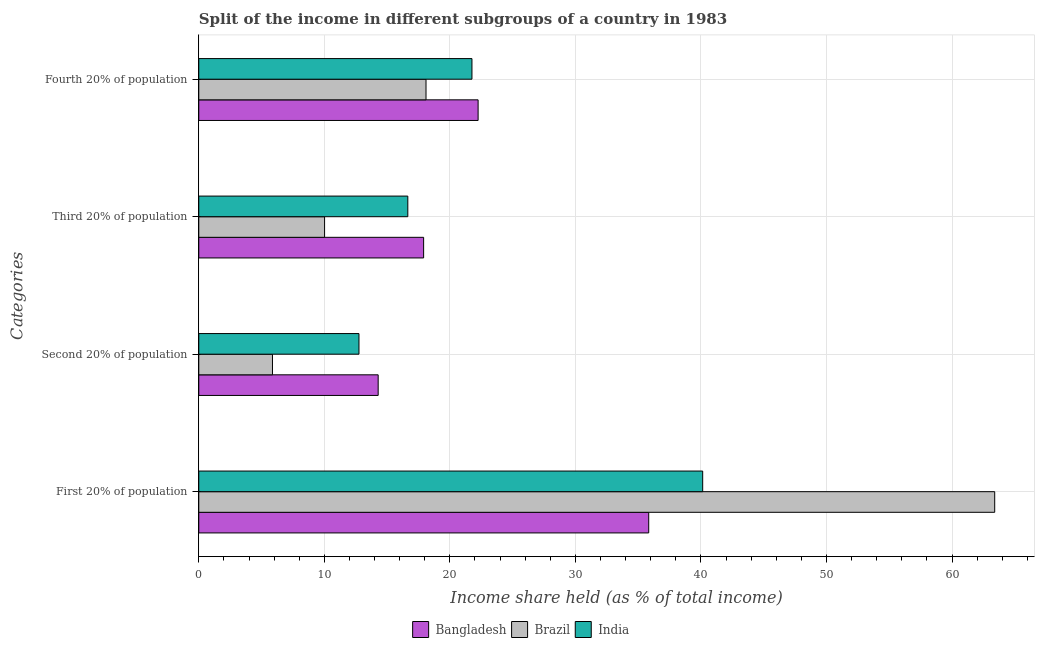How many different coloured bars are there?
Give a very brief answer. 3. How many groups of bars are there?
Your answer should be very brief. 4. Are the number of bars per tick equal to the number of legend labels?
Keep it short and to the point. Yes. Are the number of bars on each tick of the Y-axis equal?
Make the answer very short. Yes. How many bars are there on the 4th tick from the top?
Your response must be concise. 3. How many bars are there on the 3rd tick from the bottom?
Your answer should be very brief. 3. What is the label of the 4th group of bars from the top?
Provide a short and direct response. First 20% of population. What is the share of the income held by first 20% of the population in India?
Give a very brief answer. 40.14. Across all countries, what is the maximum share of the income held by second 20% of the population?
Offer a very short reply. 14.29. Across all countries, what is the minimum share of the income held by first 20% of the population?
Your answer should be very brief. 35.84. In which country was the share of the income held by fourth 20% of the population maximum?
Ensure brevity in your answer.  Bangladesh. In which country was the share of the income held by third 20% of the population minimum?
Provide a succinct answer. Brazil. What is the total share of the income held by second 20% of the population in the graph?
Your answer should be very brief. 32.92. What is the difference between the share of the income held by second 20% of the population in India and that in Bangladesh?
Your response must be concise. -1.53. What is the difference between the share of the income held by first 20% of the population in India and the share of the income held by fourth 20% of the population in Brazil?
Ensure brevity in your answer.  22.04. What is the average share of the income held by first 20% of the population per country?
Offer a terse response. 46.46. What is the difference between the share of the income held by second 20% of the population and share of the income held by third 20% of the population in Brazil?
Make the answer very short. -4.15. In how many countries, is the share of the income held by second 20% of the population greater than 34 %?
Offer a terse response. 0. What is the ratio of the share of the income held by second 20% of the population in India to that in Brazil?
Keep it short and to the point. 2.17. What is the difference between the highest and the second highest share of the income held by fourth 20% of the population?
Offer a very short reply. 0.49. What is the difference between the highest and the lowest share of the income held by third 20% of the population?
Offer a terse response. 7.89. Is the sum of the share of the income held by first 20% of the population in Bangladesh and Brazil greater than the maximum share of the income held by fourth 20% of the population across all countries?
Your response must be concise. Yes. What does the 3rd bar from the top in First 20% of population represents?
Your answer should be very brief. Bangladesh. Are all the bars in the graph horizontal?
Give a very brief answer. Yes. How many countries are there in the graph?
Offer a very short reply. 3. Does the graph contain grids?
Offer a very short reply. Yes. Where does the legend appear in the graph?
Provide a succinct answer. Bottom center. How many legend labels are there?
Keep it short and to the point. 3. How are the legend labels stacked?
Provide a succinct answer. Horizontal. What is the title of the graph?
Offer a terse response. Split of the income in different subgroups of a country in 1983. Does "Greece" appear as one of the legend labels in the graph?
Your answer should be very brief. No. What is the label or title of the X-axis?
Ensure brevity in your answer.  Income share held (as % of total income). What is the label or title of the Y-axis?
Provide a succinct answer. Categories. What is the Income share held (as % of total income) of Bangladesh in First 20% of population?
Offer a terse response. 35.84. What is the Income share held (as % of total income) of Brazil in First 20% of population?
Your answer should be compact. 63.4. What is the Income share held (as % of total income) in India in First 20% of population?
Your answer should be compact. 40.14. What is the Income share held (as % of total income) of Bangladesh in Second 20% of population?
Keep it short and to the point. 14.29. What is the Income share held (as % of total income) in Brazil in Second 20% of population?
Your answer should be very brief. 5.87. What is the Income share held (as % of total income) in India in Second 20% of population?
Provide a short and direct response. 12.76. What is the Income share held (as % of total income) in Bangladesh in Third 20% of population?
Keep it short and to the point. 17.91. What is the Income share held (as % of total income) in Brazil in Third 20% of population?
Give a very brief answer. 10.02. What is the Income share held (as % of total income) in India in Third 20% of population?
Your answer should be compact. 16.65. What is the Income share held (as % of total income) of Bangladesh in Fourth 20% of population?
Make the answer very short. 22.25. What is the Income share held (as % of total income) in Brazil in Fourth 20% of population?
Offer a terse response. 18.1. What is the Income share held (as % of total income) in India in Fourth 20% of population?
Make the answer very short. 21.76. Across all Categories, what is the maximum Income share held (as % of total income) of Bangladesh?
Your answer should be very brief. 35.84. Across all Categories, what is the maximum Income share held (as % of total income) of Brazil?
Make the answer very short. 63.4. Across all Categories, what is the maximum Income share held (as % of total income) in India?
Your answer should be very brief. 40.14. Across all Categories, what is the minimum Income share held (as % of total income) of Bangladesh?
Offer a terse response. 14.29. Across all Categories, what is the minimum Income share held (as % of total income) of Brazil?
Provide a succinct answer. 5.87. Across all Categories, what is the minimum Income share held (as % of total income) of India?
Your answer should be compact. 12.76. What is the total Income share held (as % of total income) of Bangladesh in the graph?
Give a very brief answer. 90.29. What is the total Income share held (as % of total income) in Brazil in the graph?
Give a very brief answer. 97.39. What is the total Income share held (as % of total income) of India in the graph?
Offer a terse response. 91.31. What is the difference between the Income share held (as % of total income) in Bangladesh in First 20% of population and that in Second 20% of population?
Keep it short and to the point. 21.55. What is the difference between the Income share held (as % of total income) of Brazil in First 20% of population and that in Second 20% of population?
Your response must be concise. 57.53. What is the difference between the Income share held (as % of total income) in India in First 20% of population and that in Second 20% of population?
Your response must be concise. 27.38. What is the difference between the Income share held (as % of total income) in Bangladesh in First 20% of population and that in Third 20% of population?
Make the answer very short. 17.93. What is the difference between the Income share held (as % of total income) of Brazil in First 20% of population and that in Third 20% of population?
Offer a very short reply. 53.38. What is the difference between the Income share held (as % of total income) in India in First 20% of population and that in Third 20% of population?
Ensure brevity in your answer.  23.49. What is the difference between the Income share held (as % of total income) of Bangladesh in First 20% of population and that in Fourth 20% of population?
Your answer should be compact. 13.59. What is the difference between the Income share held (as % of total income) of Brazil in First 20% of population and that in Fourth 20% of population?
Keep it short and to the point. 45.3. What is the difference between the Income share held (as % of total income) of India in First 20% of population and that in Fourth 20% of population?
Keep it short and to the point. 18.38. What is the difference between the Income share held (as % of total income) of Bangladesh in Second 20% of population and that in Third 20% of population?
Make the answer very short. -3.62. What is the difference between the Income share held (as % of total income) in Brazil in Second 20% of population and that in Third 20% of population?
Your answer should be compact. -4.15. What is the difference between the Income share held (as % of total income) of India in Second 20% of population and that in Third 20% of population?
Offer a very short reply. -3.89. What is the difference between the Income share held (as % of total income) in Bangladesh in Second 20% of population and that in Fourth 20% of population?
Your response must be concise. -7.96. What is the difference between the Income share held (as % of total income) of Brazil in Second 20% of population and that in Fourth 20% of population?
Ensure brevity in your answer.  -12.23. What is the difference between the Income share held (as % of total income) of India in Second 20% of population and that in Fourth 20% of population?
Your answer should be compact. -9. What is the difference between the Income share held (as % of total income) in Bangladesh in Third 20% of population and that in Fourth 20% of population?
Your answer should be very brief. -4.34. What is the difference between the Income share held (as % of total income) of Brazil in Third 20% of population and that in Fourth 20% of population?
Keep it short and to the point. -8.08. What is the difference between the Income share held (as % of total income) in India in Third 20% of population and that in Fourth 20% of population?
Your answer should be very brief. -5.11. What is the difference between the Income share held (as % of total income) in Bangladesh in First 20% of population and the Income share held (as % of total income) in Brazil in Second 20% of population?
Make the answer very short. 29.97. What is the difference between the Income share held (as % of total income) in Bangladesh in First 20% of population and the Income share held (as % of total income) in India in Second 20% of population?
Offer a very short reply. 23.08. What is the difference between the Income share held (as % of total income) in Brazil in First 20% of population and the Income share held (as % of total income) in India in Second 20% of population?
Provide a succinct answer. 50.64. What is the difference between the Income share held (as % of total income) of Bangladesh in First 20% of population and the Income share held (as % of total income) of Brazil in Third 20% of population?
Your answer should be compact. 25.82. What is the difference between the Income share held (as % of total income) of Bangladesh in First 20% of population and the Income share held (as % of total income) of India in Third 20% of population?
Provide a short and direct response. 19.19. What is the difference between the Income share held (as % of total income) of Brazil in First 20% of population and the Income share held (as % of total income) of India in Third 20% of population?
Your response must be concise. 46.75. What is the difference between the Income share held (as % of total income) in Bangladesh in First 20% of population and the Income share held (as % of total income) in Brazil in Fourth 20% of population?
Your answer should be very brief. 17.74. What is the difference between the Income share held (as % of total income) in Bangladesh in First 20% of population and the Income share held (as % of total income) in India in Fourth 20% of population?
Your answer should be compact. 14.08. What is the difference between the Income share held (as % of total income) in Brazil in First 20% of population and the Income share held (as % of total income) in India in Fourth 20% of population?
Keep it short and to the point. 41.64. What is the difference between the Income share held (as % of total income) of Bangladesh in Second 20% of population and the Income share held (as % of total income) of Brazil in Third 20% of population?
Your response must be concise. 4.27. What is the difference between the Income share held (as % of total income) in Bangladesh in Second 20% of population and the Income share held (as % of total income) in India in Third 20% of population?
Provide a succinct answer. -2.36. What is the difference between the Income share held (as % of total income) in Brazil in Second 20% of population and the Income share held (as % of total income) in India in Third 20% of population?
Provide a short and direct response. -10.78. What is the difference between the Income share held (as % of total income) of Bangladesh in Second 20% of population and the Income share held (as % of total income) of Brazil in Fourth 20% of population?
Offer a terse response. -3.81. What is the difference between the Income share held (as % of total income) of Bangladesh in Second 20% of population and the Income share held (as % of total income) of India in Fourth 20% of population?
Your answer should be very brief. -7.47. What is the difference between the Income share held (as % of total income) in Brazil in Second 20% of population and the Income share held (as % of total income) in India in Fourth 20% of population?
Keep it short and to the point. -15.89. What is the difference between the Income share held (as % of total income) of Bangladesh in Third 20% of population and the Income share held (as % of total income) of Brazil in Fourth 20% of population?
Provide a succinct answer. -0.19. What is the difference between the Income share held (as % of total income) of Bangladesh in Third 20% of population and the Income share held (as % of total income) of India in Fourth 20% of population?
Your response must be concise. -3.85. What is the difference between the Income share held (as % of total income) in Brazil in Third 20% of population and the Income share held (as % of total income) in India in Fourth 20% of population?
Your answer should be compact. -11.74. What is the average Income share held (as % of total income) of Bangladesh per Categories?
Give a very brief answer. 22.57. What is the average Income share held (as % of total income) in Brazil per Categories?
Your response must be concise. 24.35. What is the average Income share held (as % of total income) of India per Categories?
Provide a short and direct response. 22.83. What is the difference between the Income share held (as % of total income) of Bangladesh and Income share held (as % of total income) of Brazil in First 20% of population?
Your answer should be compact. -27.56. What is the difference between the Income share held (as % of total income) in Brazil and Income share held (as % of total income) in India in First 20% of population?
Keep it short and to the point. 23.26. What is the difference between the Income share held (as % of total income) in Bangladesh and Income share held (as % of total income) in Brazil in Second 20% of population?
Keep it short and to the point. 8.42. What is the difference between the Income share held (as % of total income) in Bangladesh and Income share held (as % of total income) in India in Second 20% of population?
Give a very brief answer. 1.53. What is the difference between the Income share held (as % of total income) of Brazil and Income share held (as % of total income) of India in Second 20% of population?
Your response must be concise. -6.89. What is the difference between the Income share held (as % of total income) in Bangladesh and Income share held (as % of total income) in Brazil in Third 20% of population?
Provide a short and direct response. 7.89. What is the difference between the Income share held (as % of total income) of Bangladesh and Income share held (as % of total income) of India in Third 20% of population?
Your answer should be compact. 1.26. What is the difference between the Income share held (as % of total income) in Brazil and Income share held (as % of total income) in India in Third 20% of population?
Ensure brevity in your answer.  -6.63. What is the difference between the Income share held (as % of total income) in Bangladesh and Income share held (as % of total income) in Brazil in Fourth 20% of population?
Provide a short and direct response. 4.15. What is the difference between the Income share held (as % of total income) of Bangladesh and Income share held (as % of total income) of India in Fourth 20% of population?
Give a very brief answer. 0.49. What is the difference between the Income share held (as % of total income) of Brazil and Income share held (as % of total income) of India in Fourth 20% of population?
Your answer should be compact. -3.66. What is the ratio of the Income share held (as % of total income) of Bangladesh in First 20% of population to that in Second 20% of population?
Provide a short and direct response. 2.51. What is the ratio of the Income share held (as % of total income) in Brazil in First 20% of population to that in Second 20% of population?
Your answer should be compact. 10.8. What is the ratio of the Income share held (as % of total income) of India in First 20% of population to that in Second 20% of population?
Offer a very short reply. 3.15. What is the ratio of the Income share held (as % of total income) in Bangladesh in First 20% of population to that in Third 20% of population?
Offer a terse response. 2. What is the ratio of the Income share held (as % of total income) in Brazil in First 20% of population to that in Third 20% of population?
Offer a very short reply. 6.33. What is the ratio of the Income share held (as % of total income) in India in First 20% of population to that in Third 20% of population?
Provide a succinct answer. 2.41. What is the ratio of the Income share held (as % of total income) in Bangladesh in First 20% of population to that in Fourth 20% of population?
Ensure brevity in your answer.  1.61. What is the ratio of the Income share held (as % of total income) of Brazil in First 20% of population to that in Fourth 20% of population?
Provide a succinct answer. 3.5. What is the ratio of the Income share held (as % of total income) in India in First 20% of population to that in Fourth 20% of population?
Your answer should be very brief. 1.84. What is the ratio of the Income share held (as % of total income) of Bangladesh in Second 20% of population to that in Third 20% of population?
Provide a succinct answer. 0.8. What is the ratio of the Income share held (as % of total income) in Brazil in Second 20% of population to that in Third 20% of population?
Keep it short and to the point. 0.59. What is the ratio of the Income share held (as % of total income) of India in Second 20% of population to that in Third 20% of population?
Your answer should be compact. 0.77. What is the ratio of the Income share held (as % of total income) of Bangladesh in Second 20% of population to that in Fourth 20% of population?
Your response must be concise. 0.64. What is the ratio of the Income share held (as % of total income) in Brazil in Second 20% of population to that in Fourth 20% of population?
Your answer should be very brief. 0.32. What is the ratio of the Income share held (as % of total income) of India in Second 20% of population to that in Fourth 20% of population?
Keep it short and to the point. 0.59. What is the ratio of the Income share held (as % of total income) of Bangladesh in Third 20% of population to that in Fourth 20% of population?
Your answer should be very brief. 0.8. What is the ratio of the Income share held (as % of total income) in Brazil in Third 20% of population to that in Fourth 20% of population?
Provide a short and direct response. 0.55. What is the ratio of the Income share held (as % of total income) of India in Third 20% of population to that in Fourth 20% of population?
Offer a very short reply. 0.77. What is the difference between the highest and the second highest Income share held (as % of total income) in Bangladesh?
Ensure brevity in your answer.  13.59. What is the difference between the highest and the second highest Income share held (as % of total income) of Brazil?
Your response must be concise. 45.3. What is the difference between the highest and the second highest Income share held (as % of total income) in India?
Your response must be concise. 18.38. What is the difference between the highest and the lowest Income share held (as % of total income) in Bangladesh?
Your response must be concise. 21.55. What is the difference between the highest and the lowest Income share held (as % of total income) in Brazil?
Provide a short and direct response. 57.53. What is the difference between the highest and the lowest Income share held (as % of total income) in India?
Offer a very short reply. 27.38. 